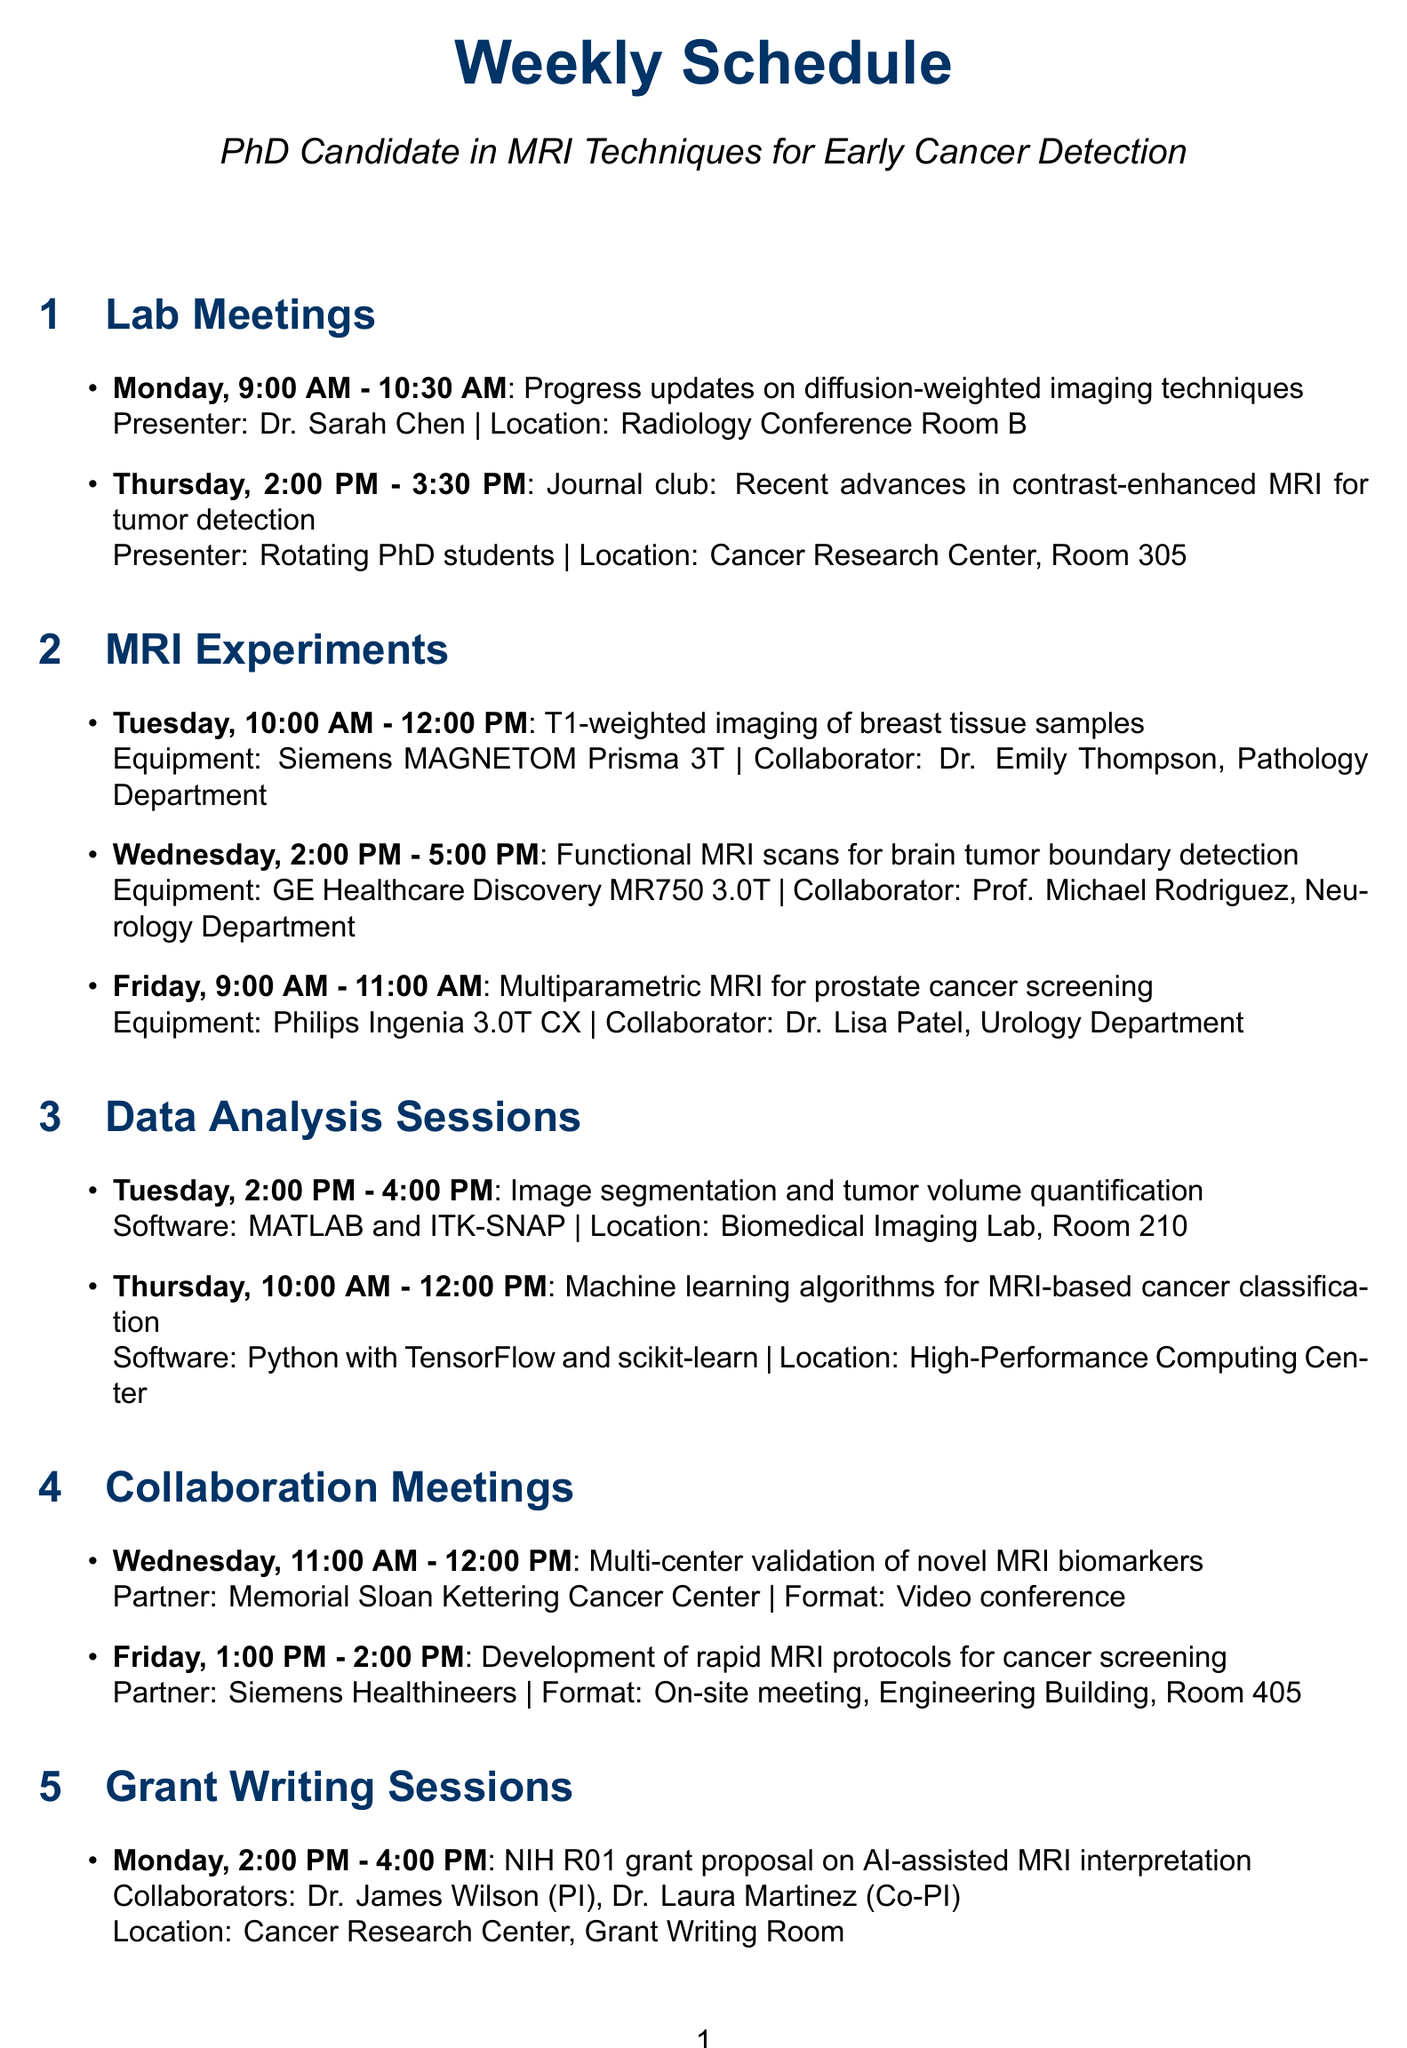what is the time for the lab meeting on Monday? The time for the lab meeting on Monday is listed in the schedule.
Answer: 9:00 AM - 10:30 AM who is presenting at the journal club on Thursday? The presenter for the journal club on Thursday is mentioned in the document.
Answer: Rotating PhD students which equipment is used for the T1-weighted imaging of breast tissue samples? The equipment for the T1-weighted imaging experiment is specified in the MRI experiments section.
Answer: Siemens MAGNETOM Prisma 3T how long is the data analysis session on Tuesday? The duration of the data analysis session on Tuesday can be calculated from the start and end time provided in the document.
Answer: 2 hours which department is collaborating on the functional MRI scans on Wednesday? The collaborating department for the functional MRI scans is stated in the document.
Answer: Neurology Department how many grant writing sessions are scheduled for Monday? The number of grant writing sessions on Monday can be found in the schedule.
Answer: 1 what is the focus of the individual mentoring session on Friday? The topic of the individual mentoring session on Friday is described in the document.
Answer: Dissertation progress and career development when is the collaboration meeting with Siemens Healthineers? The schedule specifies the day and time for the meeting with Siemens Healthineers.
Answer: Friday, 1:00 PM - 2:00 PM 